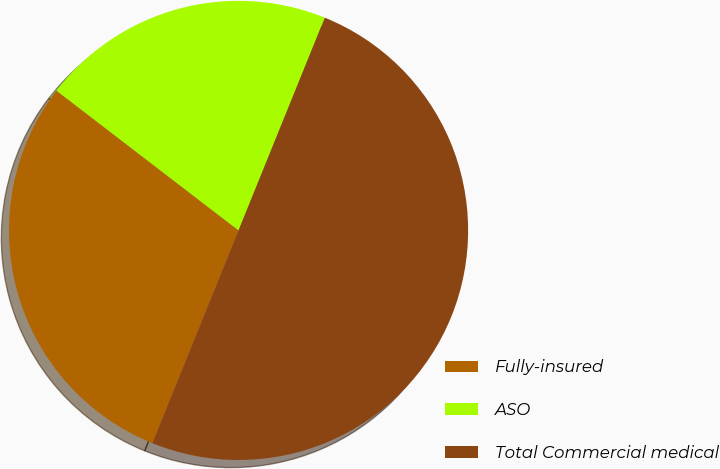Convert chart to OTSL. <chart><loc_0><loc_0><loc_500><loc_500><pie_chart><fcel>Fully-insured<fcel>ASO<fcel>Total Commercial medical<nl><fcel>29.29%<fcel>20.71%<fcel>50.0%<nl></chart> 